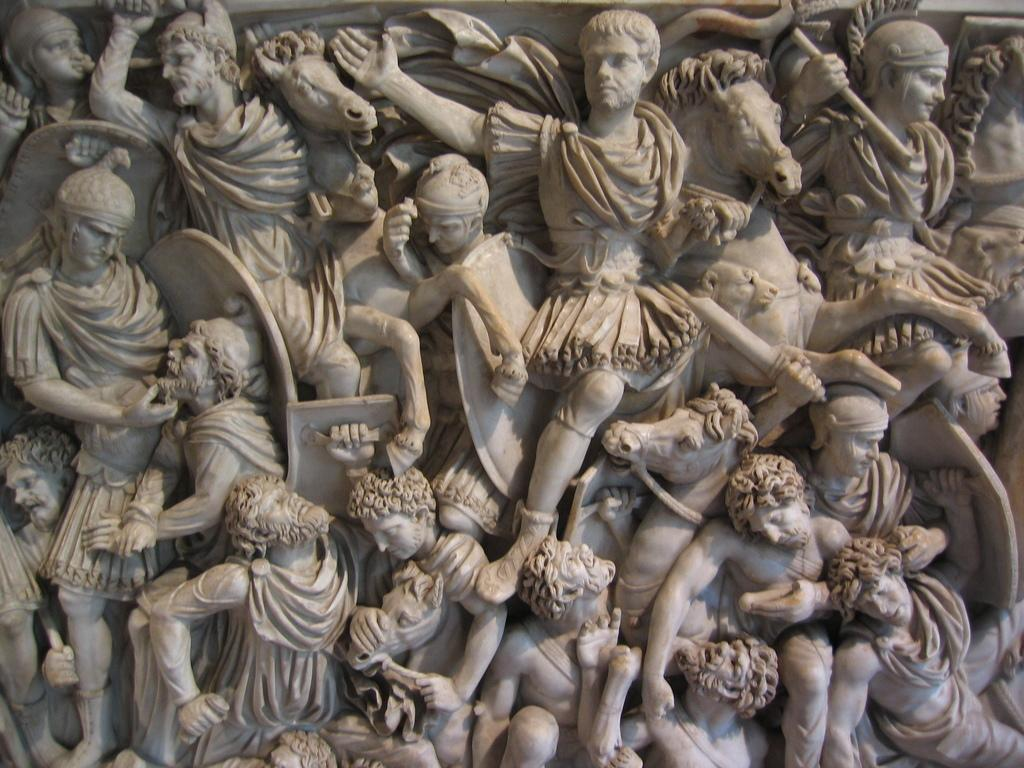What is the main subject of the picture? The main subject of the picture is a sculpture. What does the sculpture depict? The sculpture depicts men and horses. What type of steel is used to create the slope in the sculpture? There is no slope present in the sculpture, and it is not made of steel. The sculpture depicts men and horses. 